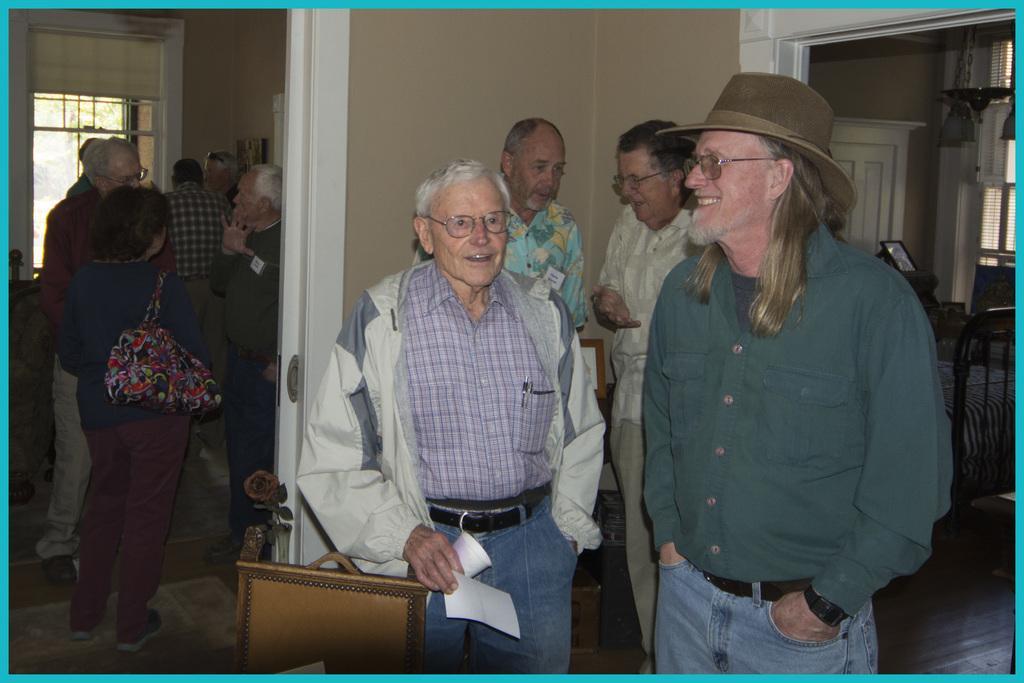Can you describe this image briefly? In this image I can see a person wearing green and blue dress and another person wearing blue jeans and white jacket are standing. In the background I can see few other persons standing, the brown colored wall, the bed, the door and the window. 